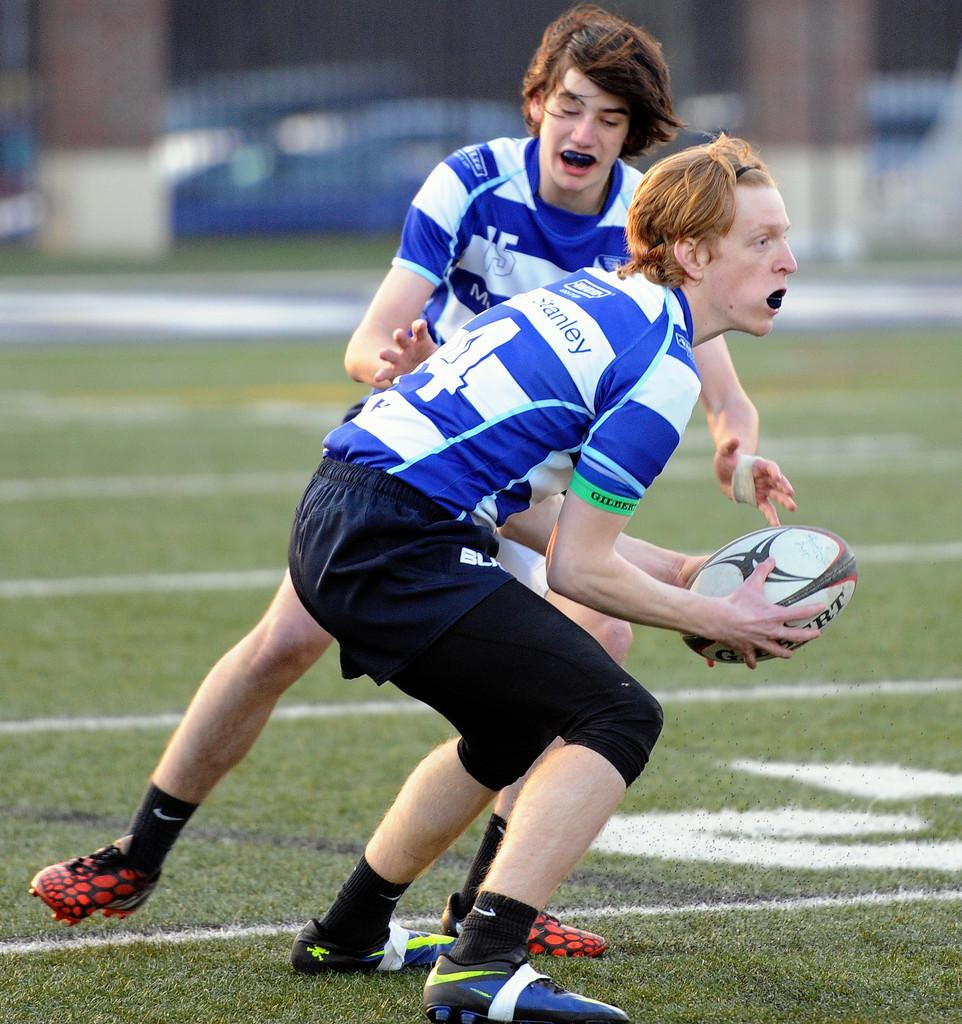How many people are in the image? There are two men in the image. What activity are the men engaged in? The men are playing American football. Who has possession of the ball? One person is holding the ball. What type of surface is the game being played on? There is grass on the ground. Can you describe the background of the image? The background of the image is blurred. What type of poison is being used to quilt the men's teeth in the image? There is no poison, quilting, or teeth present in the image. 